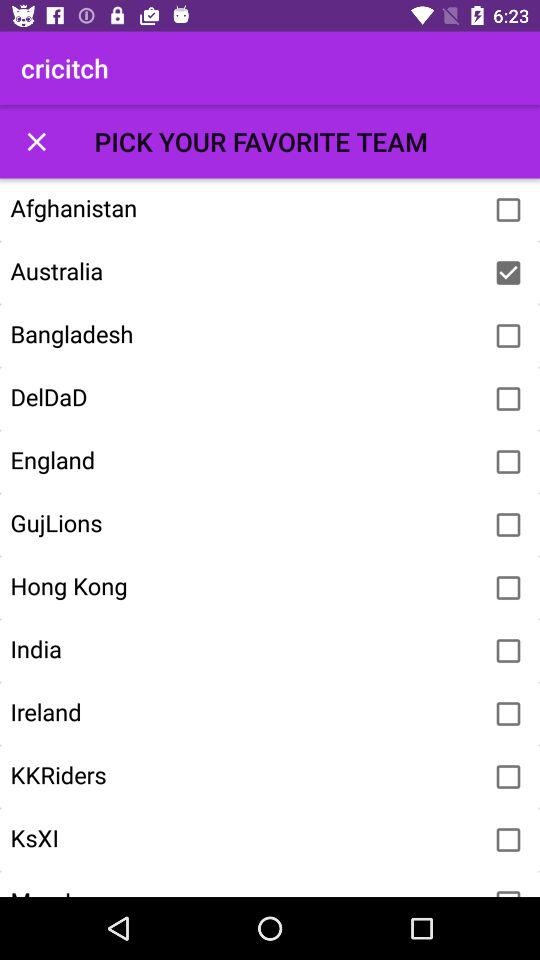What team was selected? The selected team is "Australia". 